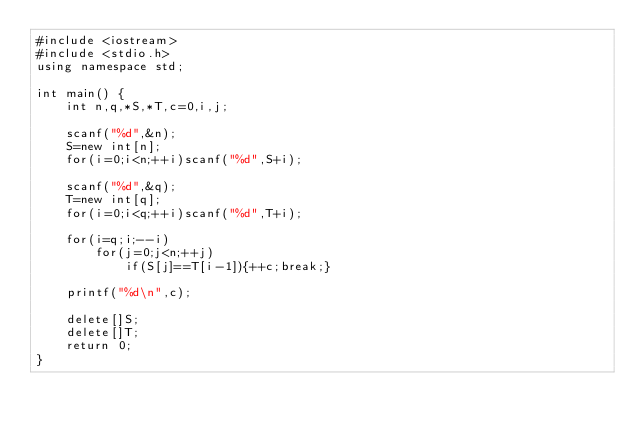Convert code to text. <code><loc_0><loc_0><loc_500><loc_500><_C++_>#include <iostream>
#include <stdio.h>
using namespace std;
  
int main() {
    int n,q,*S,*T,c=0,i,j;
     
    scanf("%d",&n);
    S=new int[n];
    for(i=0;i<n;++i)scanf("%d",S+i);
      
    scanf("%d",&q);
    T=new int[q];
    for(i=0;i<q;++i)scanf("%d",T+i);
      
    for(i=q;i;--i)
        for(j=0;j<n;++j)
            if(S[j]==T[i-1]){++c;break;}
      
    printf("%d\n",c);
      
    delete[]S;
    delete[]T;
    return 0;
}</code> 